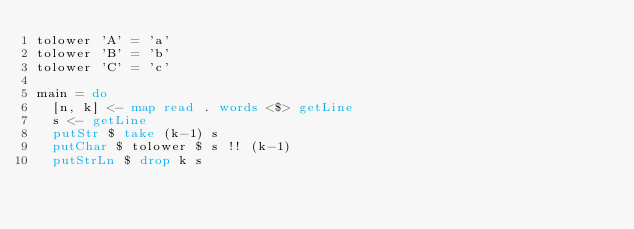<code> <loc_0><loc_0><loc_500><loc_500><_Haskell_>tolower 'A' = 'a'
tolower 'B' = 'b'
tolower 'C' = 'c'

main = do
  [n, k] <- map read . words <$> getLine
  s <- getLine
  putStr $ take (k-1) s
  putChar $ tolower $ s !! (k-1)
  putStrLn $ drop k s</code> 